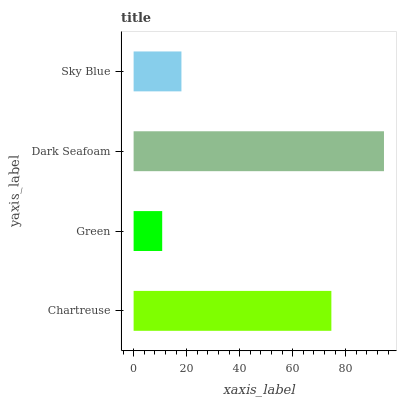Is Green the minimum?
Answer yes or no. Yes. Is Dark Seafoam the maximum?
Answer yes or no. Yes. Is Dark Seafoam the minimum?
Answer yes or no. No. Is Green the maximum?
Answer yes or no. No. Is Dark Seafoam greater than Green?
Answer yes or no. Yes. Is Green less than Dark Seafoam?
Answer yes or no. Yes. Is Green greater than Dark Seafoam?
Answer yes or no. No. Is Dark Seafoam less than Green?
Answer yes or no. No. Is Chartreuse the high median?
Answer yes or no. Yes. Is Sky Blue the low median?
Answer yes or no. Yes. Is Sky Blue the high median?
Answer yes or no. No. Is Dark Seafoam the low median?
Answer yes or no. No. 